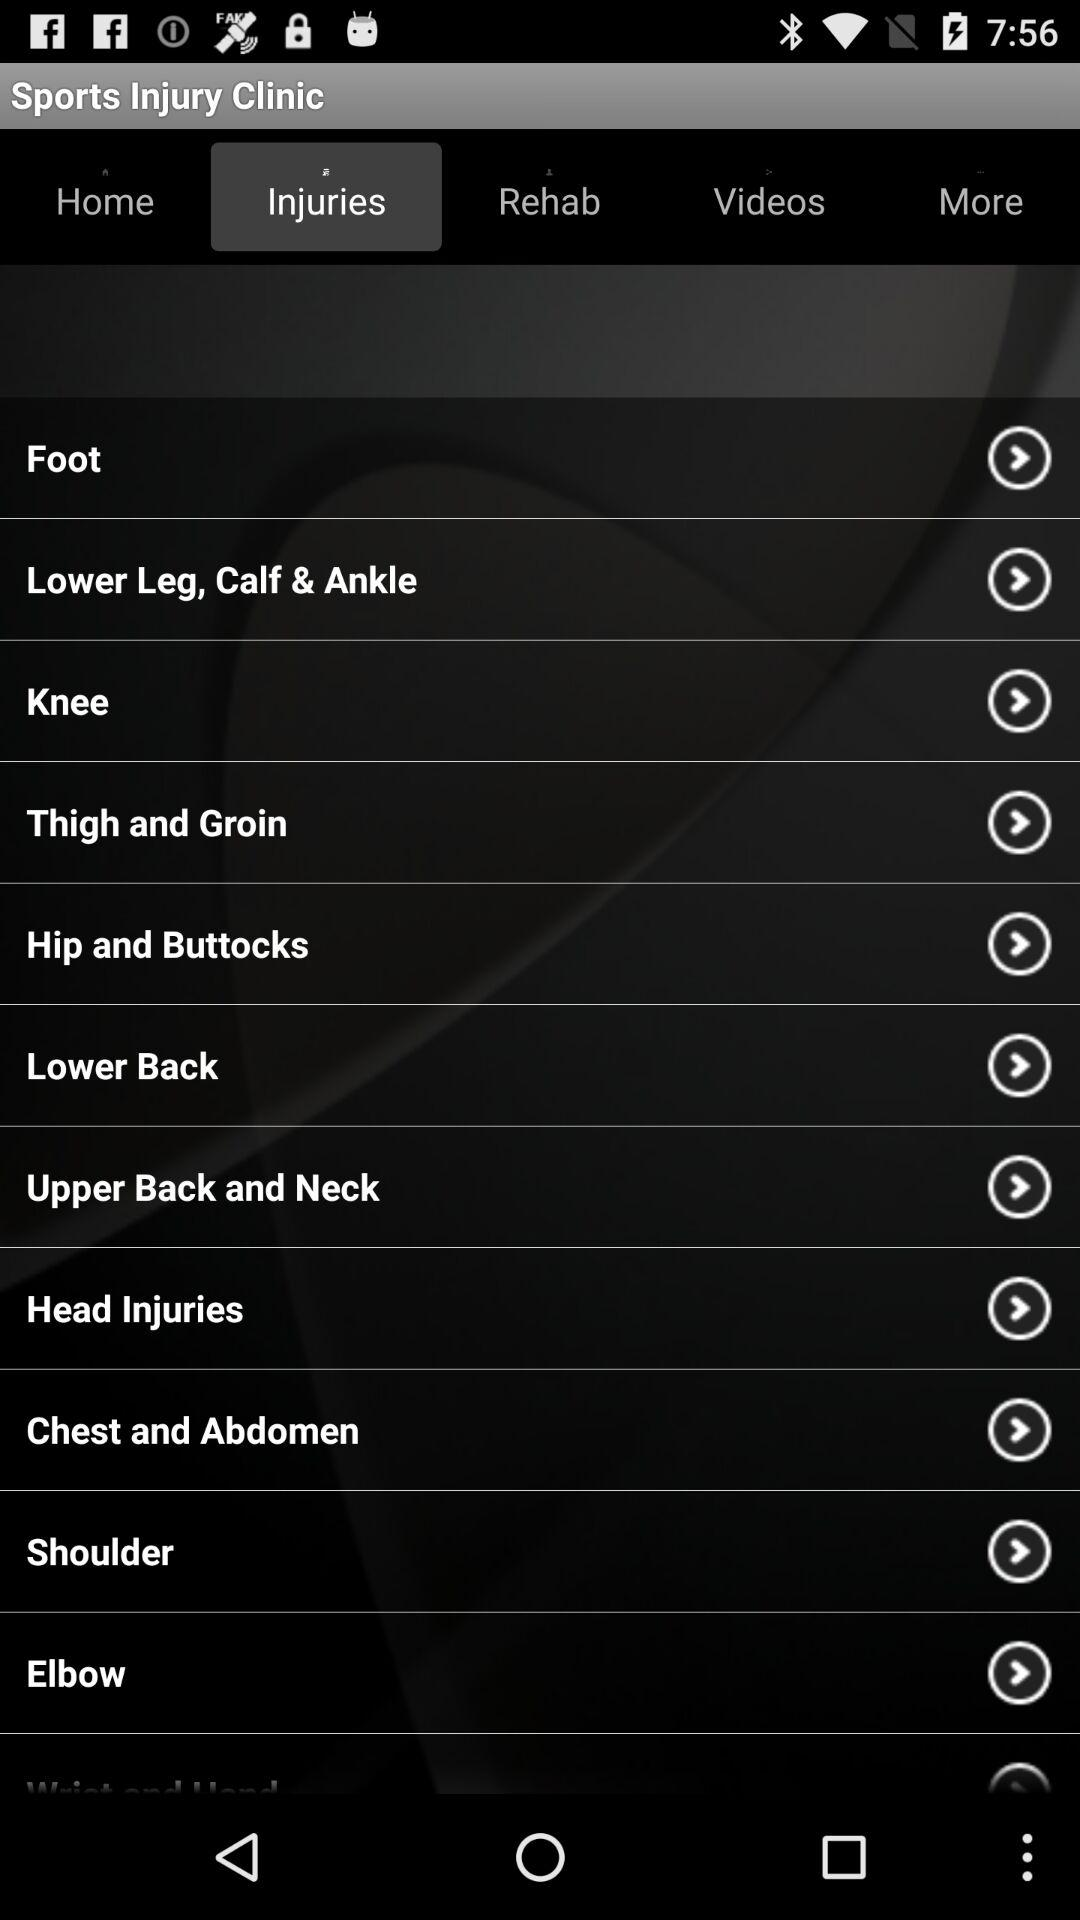Which tab is selected? The selected tab is "Injuries". 